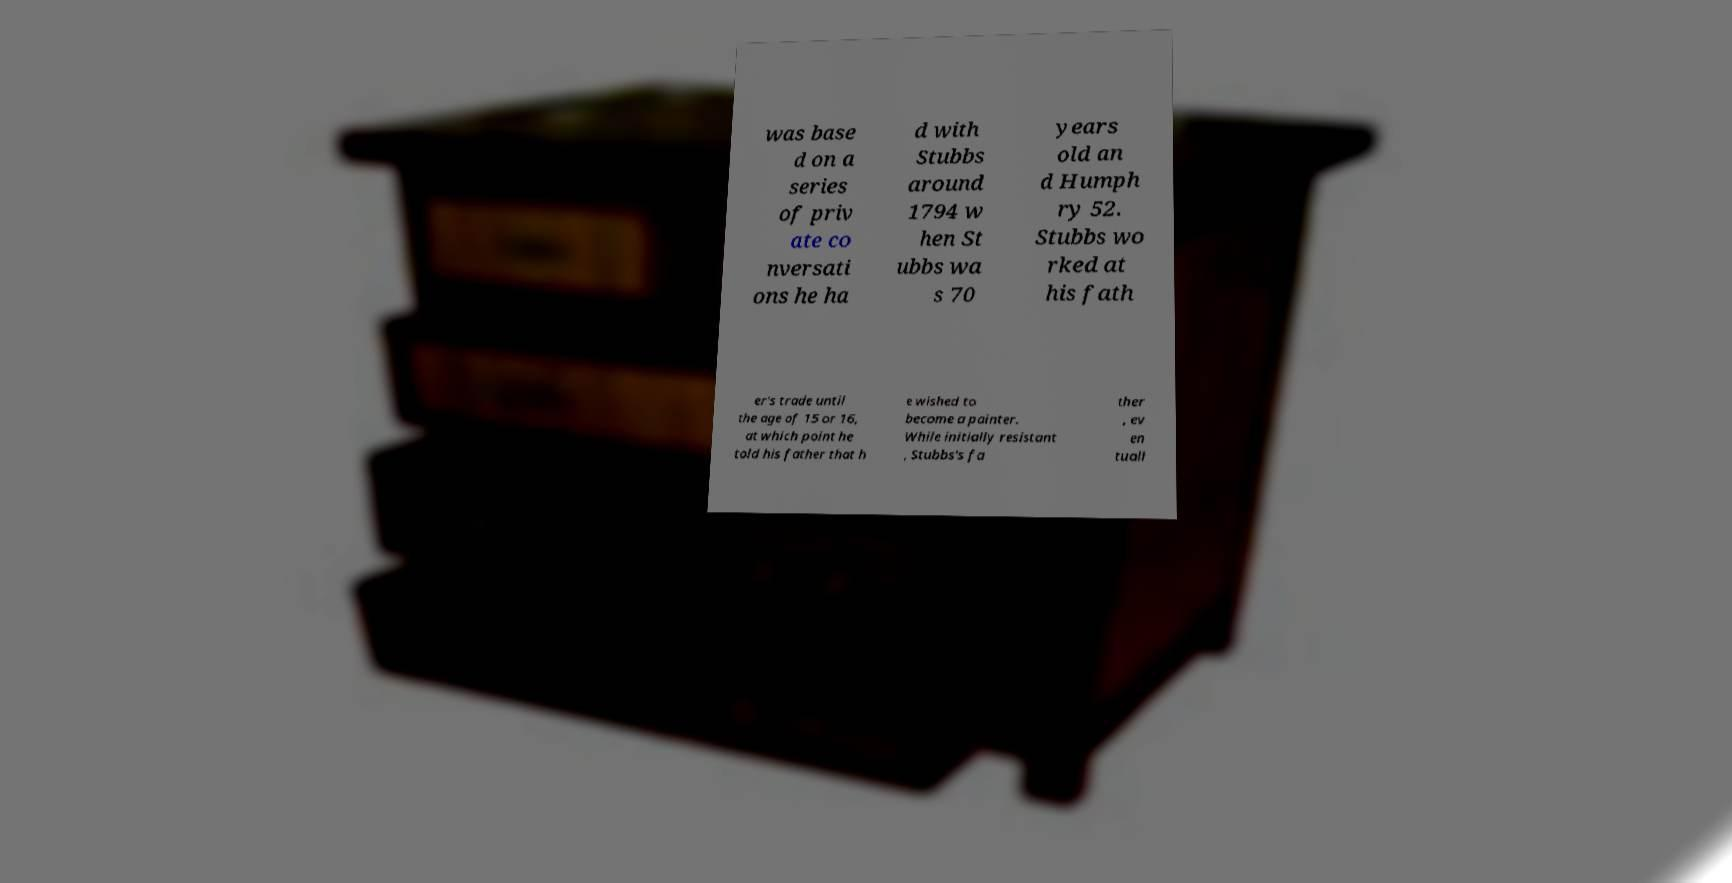I need the written content from this picture converted into text. Can you do that? was base d on a series of priv ate co nversati ons he ha d with Stubbs around 1794 w hen St ubbs wa s 70 years old an d Humph ry 52. Stubbs wo rked at his fath er's trade until the age of 15 or 16, at which point he told his father that h e wished to become a painter. While initially resistant , Stubbs's fa ther , ev en tuall 